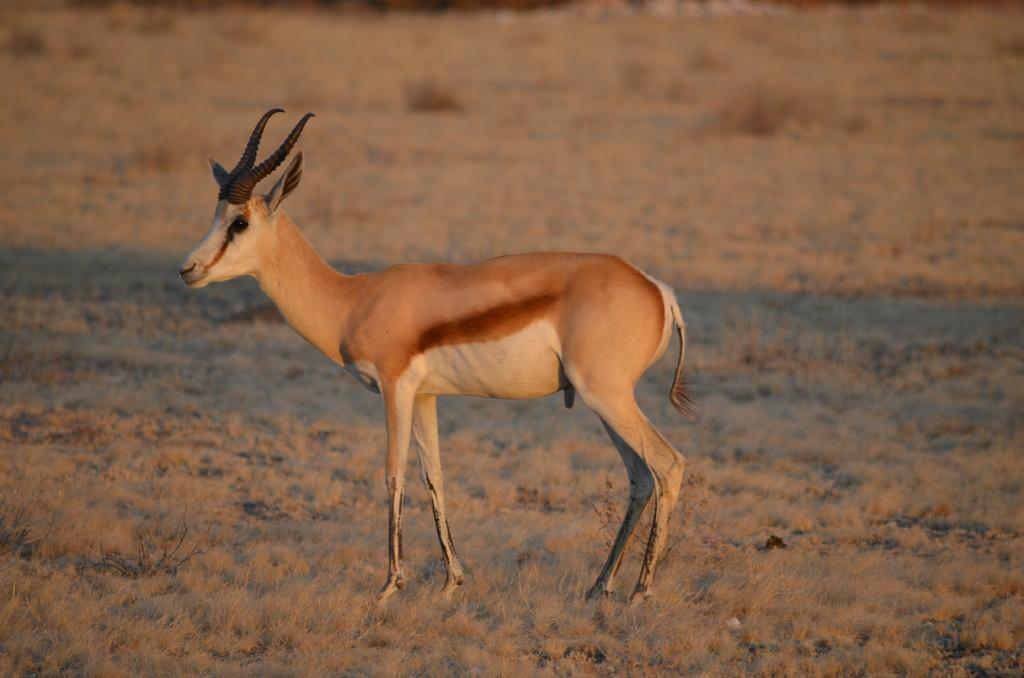What type of creature can be seen in the image? There is an animal in the image. Where is the animal located in the image? The animal is on the ground. Can you describe the background of the image? The background of the image is blurred. What type of advertisement can be seen in the image? There is no advertisement present in the image; it features an animal on the ground with a blurred background. 